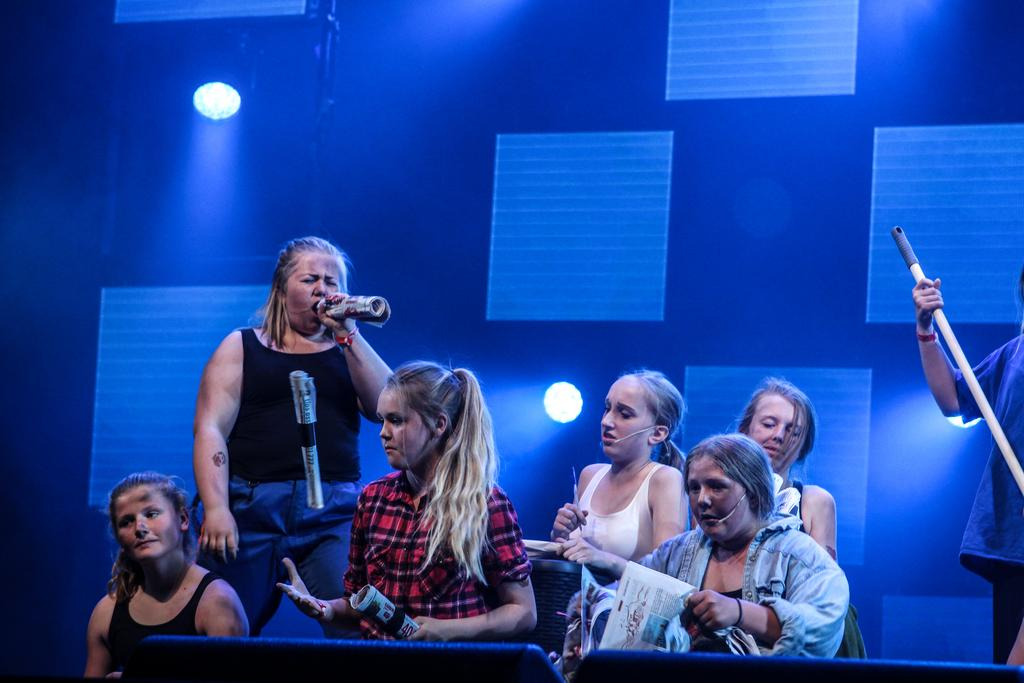How many people are in the image? There is a group of people in the image, but the exact number cannot be determined from the provided facts. What else can be seen in the image besides the group of people? There are objects in the image. What can be seen in the background of the image? There are lights and a wall visible in the background of the image. What type of print can be seen on the veil worn by the person in the image? There is no veil or print mentioned in the provided facts, so it cannot be determined from the image. 